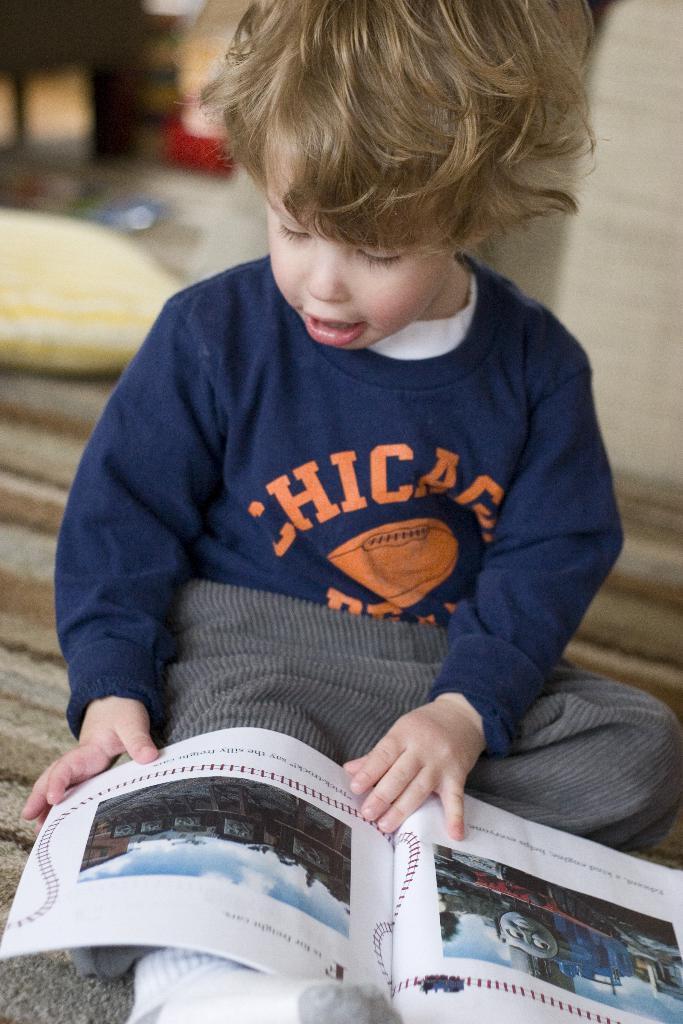Please provide a concise description of this image. In this image we can see a boy sitting and holding a book, in the background, we can see a pillow, wall and some other objects. 